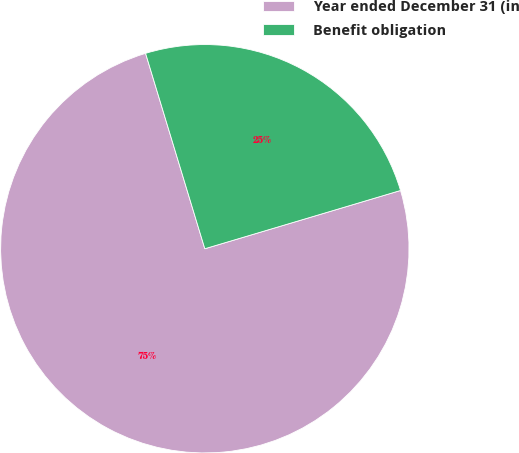Convert chart. <chart><loc_0><loc_0><loc_500><loc_500><pie_chart><fcel>Year ended December 31 (in<fcel>Benefit obligation<nl><fcel>74.92%<fcel>25.08%<nl></chart> 